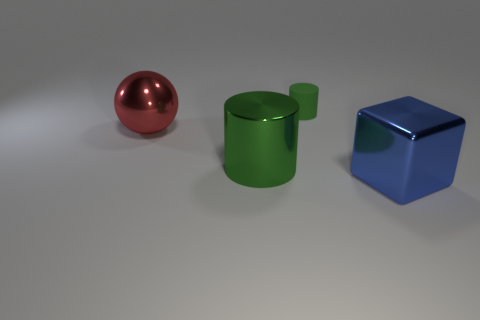Do the metallic cylinder and the matte cylinder have the same color?
Provide a short and direct response. Yes. Are there any other things that have the same shape as the large blue object?
Provide a succinct answer. No. Are there fewer shiny blocks behind the big cylinder than red balls?
Your response must be concise. Yes. There is a metal cylinder that is to the right of the red ball; is its color the same as the tiny matte object?
Your response must be concise. Yes. How many metallic things are cylinders or balls?
Provide a short and direct response. 2. Is there anything else that has the same size as the green rubber cylinder?
Your answer should be compact. No. The block that is made of the same material as the large cylinder is what color?
Provide a succinct answer. Blue. How many cubes are tiny blue objects or green matte things?
Your response must be concise. 0. What number of things are shiny balls or big things right of the sphere?
Provide a short and direct response. 3. Are there any big spheres?
Offer a terse response. Yes. 